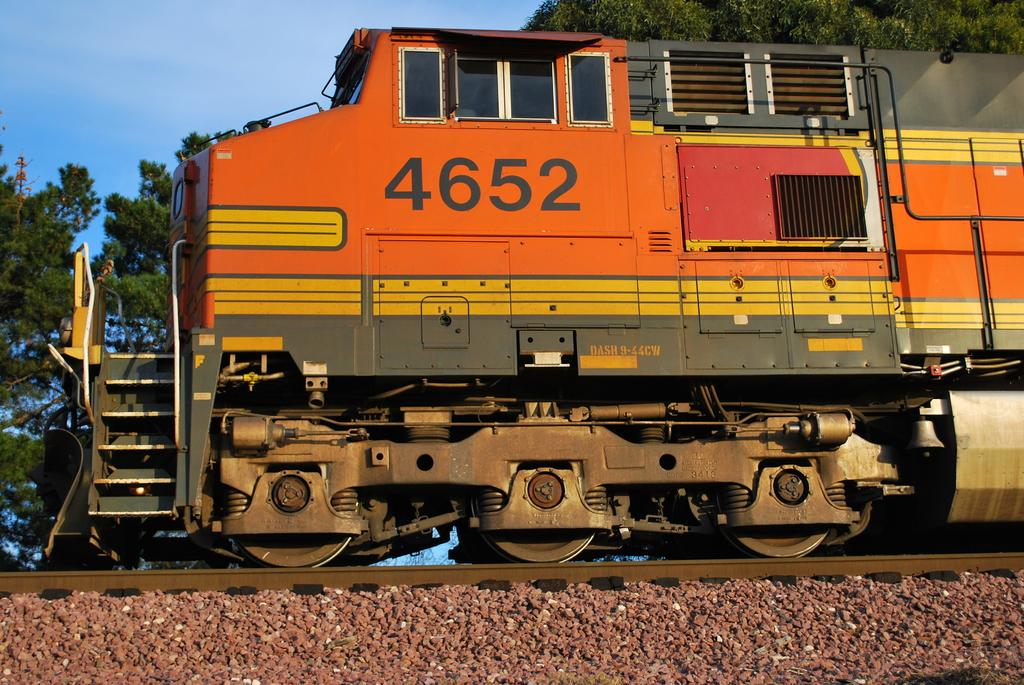What is the main subject of the image? The main subject of the image is a train engine. Where is the train engine located? The train engine is on a track. What can be seen on the side of the track? There are stones on the side of the track. What is visible in the background of the image? Trees are visible in the background of the image. What is visible in the sky in the image? The sky is visible in the image, and clouds are present. What type of milk is being delivered by the crook in the image? There is no crook or milk present in the image; it features a train engine on a track. How does the fire affect the train engine in the image? There is no fire present in the image; it features a train engine on a track with no visible signs of fire or damage. 